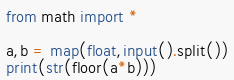Convert code to text. <code><loc_0><loc_0><loc_500><loc_500><_Python_>from math import *

a,b = map(float,input().split())
print(str(floor(a*b)))</code> 